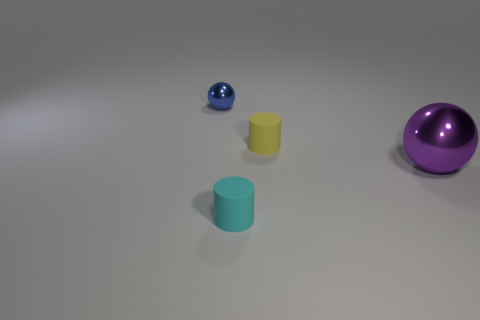Is there any other thing that is the same size as the purple metal ball?
Your answer should be compact. No. Are there any matte things right of the small matte object that is in front of the tiny yellow matte thing?
Your response must be concise. Yes. How many tiny cyan rubber cylinders are there?
Ensure brevity in your answer.  1. There is a tiny object that is in front of the blue shiny thing and behind the big purple sphere; what is its color?
Keep it short and to the point. Yellow. The purple metal thing that is the same shape as the blue object is what size?
Offer a very short reply. Large. How many other cylinders are the same size as the yellow cylinder?
Your answer should be compact. 1. What material is the purple ball?
Make the answer very short. Metal. Are there any small metal spheres behind the tiny ball?
Keep it short and to the point. No. There is a cylinder that is made of the same material as the tiny cyan object; what is its size?
Ensure brevity in your answer.  Small. Is the number of purple objects that are on the right side of the purple shiny object less than the number of tiny cylinders behind the cyan matte object?
Provide a short and direct response. Yes. 